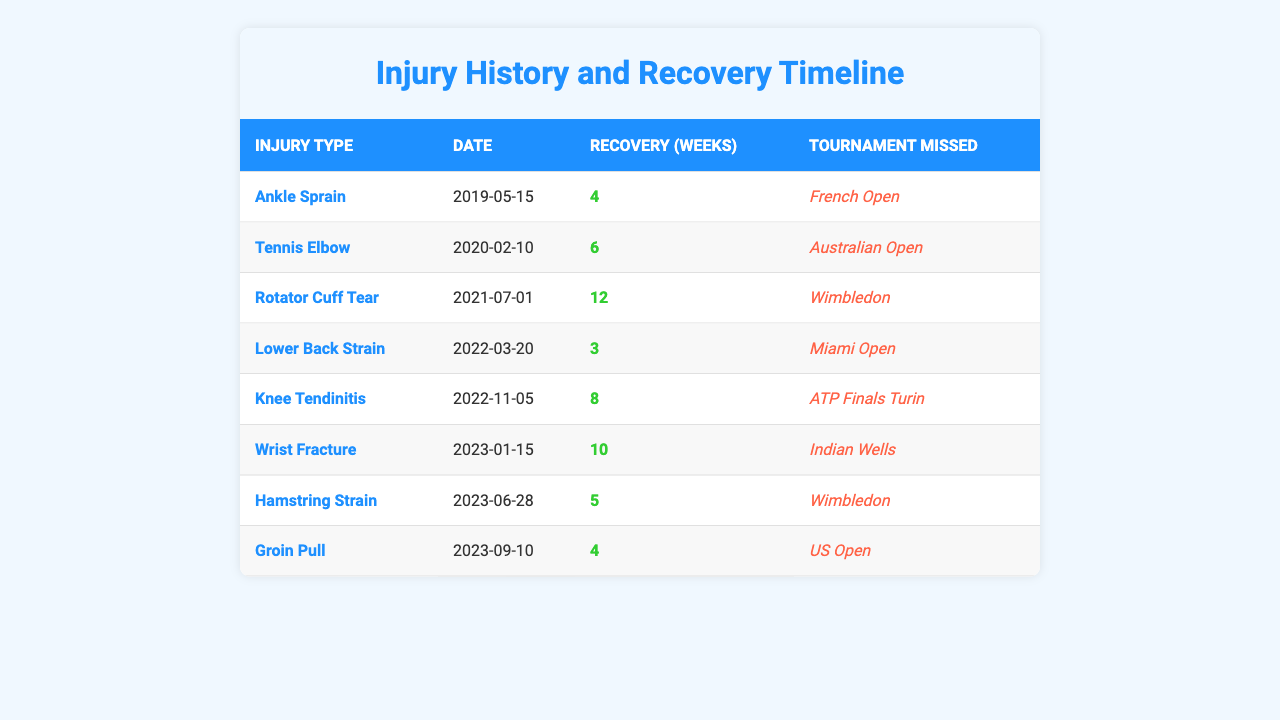What type of injury did you have on July 1, 2021? Referring to the table, the injury listed on July 1, 2021, is a "Rotator Cuff Tear."
Answer: Rotator Cuff Tear How many weeks did you miss due to the Tennis Elbow injury? The table shows that the recovery period for Tennis Elbow is 6 weeks.
Answer: 6 weeks Which tournaments were missed because of the ankle sprain? According to the table, the tournament missed due to Ankle Sprain is the "French Open."
Answer: French Open Did you miss any tournaments in 2023? Yes, the table lists two tournaments missed in 2023: "Indian Wells" and "Wimbledon."
Answer: Yes What is the longest recovery period recorded in the table? By reviewing the recovery weeks, the longest recovery period is for the "Rotator Cuff Tear," which is 12 weeks.
Answer: 12 weeks How many weeks did you recover from your knee tendinitis? The table states that the recovery period for Knee Tendinitis is 8 weeks.
Answer: 8 weeks Was any injury reported in 2022? Yes, two injuries occurred in 2022: "Lower Back Strain" and "Knee Tendinitis."
Answer: Yes What is the average recovery time for all injuries? To find the average, sum the recovery weeks (4 + 6 + 12 + 3 + 8 + 10 + 5 + 4 = 52) and divide by the number of injuries (8). The average recovery time is 52/8 = 6.5 weeks.
Answer: 6.5 weeks How many injuries caused you to miss the ATP Finals in Turin? The only injury that caused missing the ATP Finals in Turin is "Knee Tendinitis," so the count is one.
Answer: 1 If you consider the tournaments missed, which two injuries had the shortest recovery periods? From the table, "Lower Back Strain" (3 weeks) and "Groin Pull" (4 weeks) had the shortest recovery periods.
Answer: Lower Back Strain and Groin Pull 